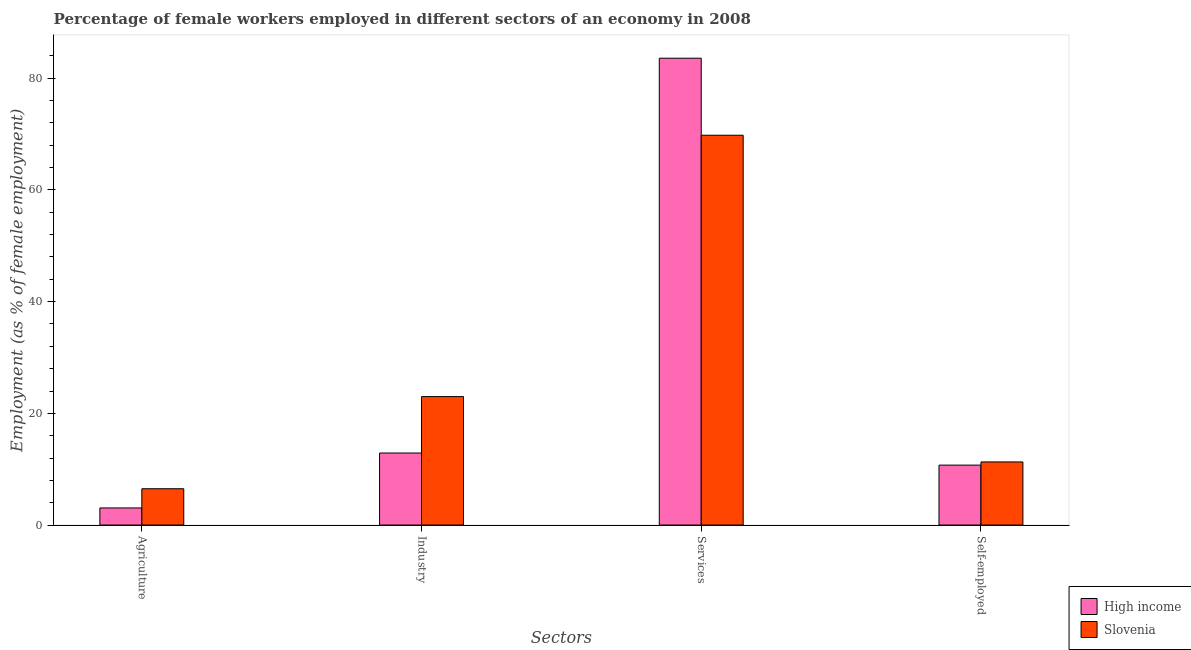Are the number of bars per tick equal to the number of legend labels?
Ensure brevity in your answer.  Yes. How many bars are there on the 1st tick from the right?
Keep it short and to the point. 2. What is the label of the 3rd group of bars from the left?
Provide a short and direct response. Services. What is the percentage of female workers in industry in Slovenia?
Provide a short and direct response. 23. Across all countries, what is the maximum percentage of female workers in industry?
Offer a very short reply. 23. Across all countries, what is the minimum percentage of female workers in services?
Your answer should be very brief. 69.8. In which country was the percentage of female workers in services maximum?
Your response must be concise. High income. What is the total percentage of female workers in industry in the graph?
Your answer should be very brief. 35.9. What is the difference between the percentage of self employed female workers in High income and that in Slovenia?
Your answer should be compact. -0.57. What is the difference between the percentage of female workers in agriculture in High income and the percentage of female workers in services in Slovenia?
Give a very brief answer. -66.74. What is the average percentage of female workers in agriculture per country?
Give a very brief answer. 4.78. What is the difference between the percentage of self employed female workers and percentage of female workers in services in Slovenia?
Keep it short and to the point. -58.5. In how many countries, is the percentage of female workers in industry greater than 52 %?
Offer a terse response. 0. What is the ratio of the percentage of self employed female workers in Slovenia to that in High income?
Provide a short and direct response. 1.05. Is the percentage of self employed female workers in High income less than that in Slovenia?
Your response must be concise. Yes. Is the difference between the percentage of female workers in agriculture in High income and Slovenia greater than the difference between the percentage of female workers in services in High income and Slovenia?
Offer a very short reply. No. What is the difference between the highest and the second highest percentage of female workers in services?
Your answer should be very brief. 13.79. What is the difference between the highest and the lowest percentage of female workers in services?
Your answer should be very brief. 13.79. What does the 2nd bar from the left in Services represents?
Ensure brevity in your answer.  Slovenia. Is it the case that in every country, the sum of the percentage of female workers in agriculture and percentage of female workers in industry is greater than the percentage of female workers in services?
Give a very brief answer. No. Are all the bars in the graph horizontal?
Give a very brief answer. No. How many countries are there in the graph?
Provide a succinct answer. 2. Does the graph contain any zero values?
Make the answer very short. No. Does the graph contain grids?
Your answer should be very brief. No. Where does the legend appear in the graph?
Give a very brief answer. Bottom right. How many legend labels are there?
Offer a very short reply. 2. What is the title of the graph?
Your response must be concise. Percentage of female workers employed in different sectors of an economy in 2008. Does "Europe(all income levels)" appear as one of the legend labels in the graph?
Give a very brief answer. No. What is the label or title of the X-axis?
Offer a terse response. Sectors. What is the label or title of the Y-axis?
Make the answer very short. Employment (as % of female employment). What is the Employment (as % of female employment) in High income in Agriculture?
Ensure brevity in your answer.  3.06. What is the Employment (as % of female employment) in Slovenia in Agriculture?
Provide a short and direct response. 6.5. What is the Employment (as % of female employment) of High income in Industry?
Offer a very short reply. 12.9. What is the Employment (as % of female employment) in Slovenia in Industry?
Keep it short and to the point. 23. What is the Employment (as % of female employment) of High income in Services?
Provide a short and direct response. 83.59. What is the Employment (as % of female employment) of Slovenia in Services?
Provide a succinct answer. 69.8. What is the Employment (as % of female employment) of High income in Self-employed?
Make the answer very short. 10.73. What is the Employment (as % of female employment) in Slovenia in Self-employed?
Provide a short and direct response. 11.3. Across all Sectors, what is the maximum Employment (as % of female employment) in High income?
Your response must be concise. 83.59. Across all Sectors, what is the maximum Employment (as % of female employment) of Slovenia?
Make the answer very short. 69.8. Across all Sectors, what is the minimum Employment (as % of female employment) in High income?
Give a very brief answer. 3.06. What is the total Employment (as % of female employment) in High income in the graph?
Provide a succinct answer. 110.28. What is the total Employment (as % of female employment) in Slovenia in the graph?
Make the answer very short. 110.6. What is the difference between the Employment (as % of female employment) in High income in Agriculture and that in Industry?
Your response must be concise. -9.84. What is the difference between the Employment (as % of female employment) in Slovenia in Agriculture and that in Industry?
Your answer should be very brief. -16.5. What is the difference between the Employment (as % of female employment) of High income in Agriculture and that in Services?
Make the answer very short. -80.53. What is the difference between the Employment (as % of female employment) of Slovenia in Agriculture and that in Services?
Provide a succinct answer. -63.3. What is the difference between the Employment (as % of female employment) in High income in Agriculture and that in Self-employed?
Your response must be concise. -7.67. What is the difference between the Employment (as % of female employment) in Slovenia in Agriculture and that in Self-employed?
Make the answer very short. -4.8. What is the difference between the Employment (as % of female employment) of High income in Industry and that in Services?
Your response must be concise. -70.69. What is the difference between the Employment (as % of female employment) in Slovenia in Industry and that in Services?
Ensure brevity in your answer.  -46.8. What is the difference between the Employment (as % of female employment) of High income in Industry and that in Self-employed?
Make the answer very short. 2.17. What is the difference between the Employment (as % of female employment) in Slovenia in Industry and that in Self-employed?
Make the answer very short. 11.7. What is the difference between the Employment (as % of female employment) of High income in Services and that in Self-employed?
Offer a terse response. 72.86. What is the difference between the Employment (as % of female employment) of Slovenia in Services and that in Self-employed?
Your answer should be very brief. 58.5. What is the difference between the Employment (as % of female employment) of High income in Agriculture and the Employment (as % of female employment) of Slovenia in Industry?
Your response must be concise. -19.94. What is the difference between the Employment (as % of female employment) of High income in Agriculture and the Employment (as % of female employment) of Slovenia in Services?
Provide a succinct answer. -66.74. What is the difference between the Employment (as % of female employment) of High income in Agriculture and the Employment (as % of female employment) of Slovenia in Self-employed?
Offer a very short reply. -8.24. What is the difference between the Employment (as % of female employment) in High income in Industry and the Employment (as % of female employment) in Slovenia in Services?
Make the answer very short. -56.9. What is the difference between the Employment (as % of female employment) of High income in Industry and the Employment (as % of female employment) of Slovenia in Self-employed?
Keep it short and to the point. 1.6. What is the difference between the Employment (as % of female employment) of High income in Services and the Employment (as % of female employment) of Slovenia in Self-employed?
Provide a succinct answer. 72.29. What is the average Employment (as % of female employment) in High income per Sectors?
Offer a terse response. 27.57. What is the average Employment (as % of female employment) in Slovenia per Sectors?
Ensure brevity in your answer.  27.65. What is the difference between the Employment (as % of female employment) in High income and Employment (as % of female employment) in Slovenia in Agriculture?
Keep it short and to the point. -3.44. What is the difference between the Employment (as % of female employment) in High income and Employment (as % of female employment) in Slovenia in Industry?
Your response must be concise. -10.1. What is the difference between the Employment (as % of female employment) in High income and Employment (as % of female employment) in Slovenia in Services?
Your answer should be compact. 13.79. What is the difference between the Employment (as % of female employment) in High income and Employment (as % of female employment) in Slovenia in Self-employed?
Your response must be concise. -0.57. What is the ratio of the Employment (as % of female employment) in High income in Agriculture to that in Industry?
Keep it short and to the point. 0.24. What is the ratio of the Employment (as % of female employment) of Slovenia in Agriculture to that in Industry?
Your response must be concise. 0.28. What is the ratio of the Employment (as % of female employment) of High income in Agriculture to that in Services?
Offer a very short reply. 0.04. What is the ratio of the Employment (as % of female employment) of Slovenia in Agriculture to that in Services?
Ensure brevity in your answer.  0.09. What is the ratio of the Employment (as % of female employment) of High income in Agriculture to that in Self-employed?
Keep it short and to the point. 0.29. What is the ratio of the Employment (as % of female employment) of Slovenia in Agriculture to that in Self-employed?
Ensure brevity in your answer.  0.58. What is the ratio of the Employment (as % of female employment) in High income in Industry to that in Services?
Offer a very short reply. 0.15. What is the ratio of the Employment (as % of female employment) of Slovenia in Industry to that in Services?
Give a very brief answer. 0.33. What is the ratio of the Employment (as % of female employment) of High income in Industry to that in Self-employed?
Your answer should be compact. 1.2. What is the ratio of the Employment (as % of female employment) in Slovenia in Industry to that in Self-employed?
Offer a terse response. 2.04. What is the ratio of the Employment (as % of female employment) of High income in Services to that in Self-employed?
Your answer should be very brief. 7.79. What is the ratio of the Employment (as % of female employment) of Slovenia in Services to that in Self-employed?
Provide a short and direct response. 6.18. What is the difference between the highest and the second highest Employment (as % of female employment) of High income?
Make the answer very short. 70.69. What is the difference between the highest and the second highest Employment (as % of female employment) in Slovenia?
Offer a terse response. 46.8. What is the difference between the highest and the lowest Employment (as % of female employment) in High income?
Your answer should be very brief. 80.53. What is the difference between the highest and the lowest Employment (as % of female employment) of Slovenia?
Keep it short and to the point. 63.3. 